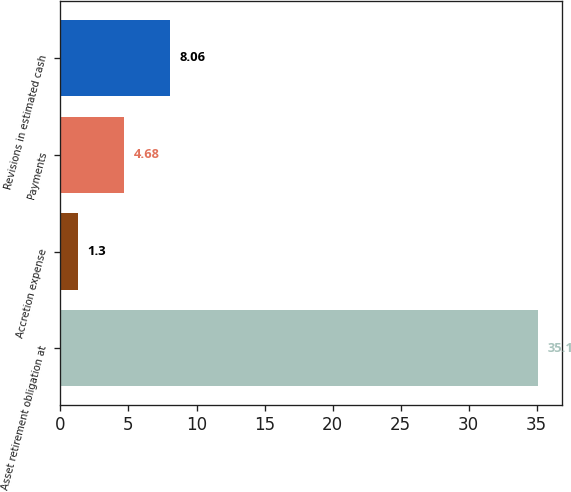Convert chart. <chart><loc_0><loc_0><loc_500><loc_500><bar_chart><fcel>Asset retirement obligation at<fcel>Accretion expense<fcel>Payments<fcel>Revisions in estimated cash<nl><fcel>35.1<fcel>1.3<fcel>4.68<fcel>8.06<nl></chart> 